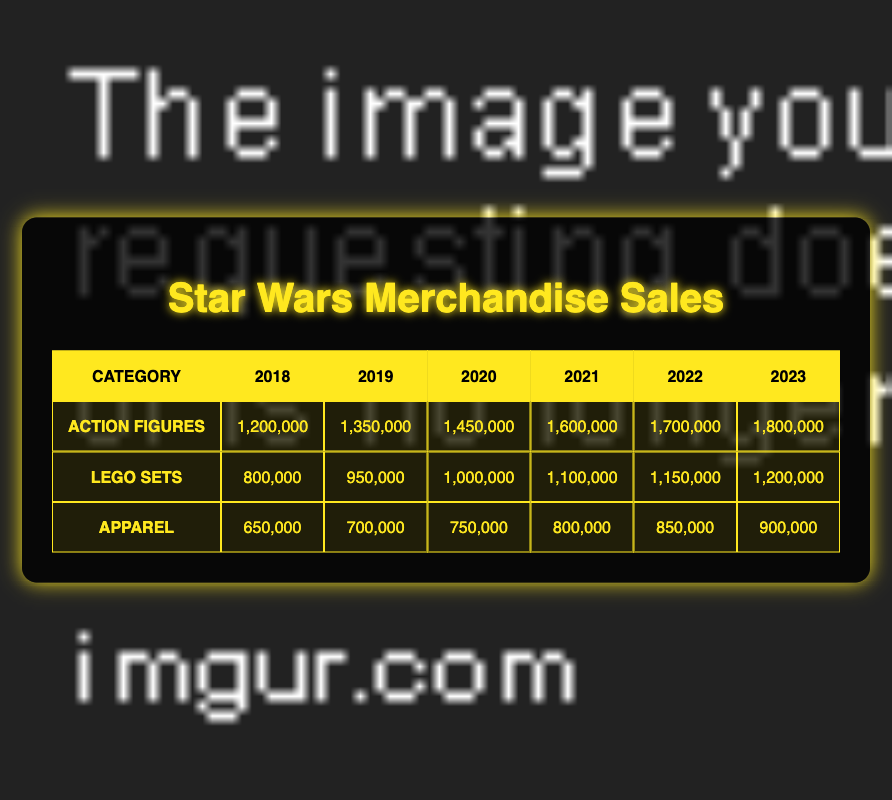What was the highest sales figure for Action Figures? The highest sales for Action Figures can be found by looking through the sales figures from each year. The values are 1,200,000 (2018), 1,350,000 (2019), 1,450,000 (2020), 1,600,000 (2021), 1,700,000 (2022), and 1,800,000 (2023). The largest among these is 1,800,000 in 2023.
Answer: 1,800,000 What category had the lowest sales in 2018? To determine which category had the lowest sales in 2018, we can look at the sales figures for each category. For 2018, the sales are: Action Figures 1,200,000, LEGO Sets 800,000, and Apparel 650,000. The lowest of these values is 650,000 from the Apparel category.
Answer: 650,000 What is the total sales for LEGO Sets from 2018 to 2023? To calculate the total sales for LEGO Sets, we need to add the sales figures for each year: 800,000 (2018) + 950,000 (2019) + 1,000,000 (2020) + 1,100,000 (2021) + 1,150,000 (2022) + 1,200,000 (2023). The total is 800,000 + 950,000 + 1,000,000 + 1,100,000 + 1,150,000 + 1,200,000 = 6,200,000.
Answer: 6,200,000 In which year did Apparel sales exceed 800,000? We need to check the Apparel sales figures for each year: 650,000 (2018), 700,000 (2019), 750,000 (2020), 800,000 (2021), 850,000 (2022), and 900,000 (2023). The first year that exceeds 800,000 is 2022.
Answer: 2022 Did Action Figures sales increase each year from 2018 to 2023? We need to compare the sales figures for Action Figures each year: 1,200,000 (2018), 1,350,000 (2019), 1,450,000 (2020), 1,600,000 (2021), 1,700,000 (2022), and 1,800,000 (2023). Since each subsequent year's sales figure is larger than the previous year's, it confirms that sales did increase each year.
Answer: Yes What was the average sales of Apparel over the years 2021 to 2023? The sales figures for Apparel from 2021 to 2023 are: 800,000 (2021), 850,000 (2022), and 900,000 (2023). First, we sum these values: 800,000 + 850,000 + 900,000 = 2,550,000. Then, we divide by the number of years: 2,550,000 / 3 = 850,000, giving us the average.
Answer: 850,000 What year had the highest sales for LEGO Sets? Looking at the sales figures for LEGO Sets each year: 800,000 (2018), 950,000 (2019), 1,000,000 (2020), 1,100,000 (2021), 1,150,000 (2022), and 1,200,000 (2023). The highest sales figure is for 2023 at 1,200,000.
Answer: 2023 